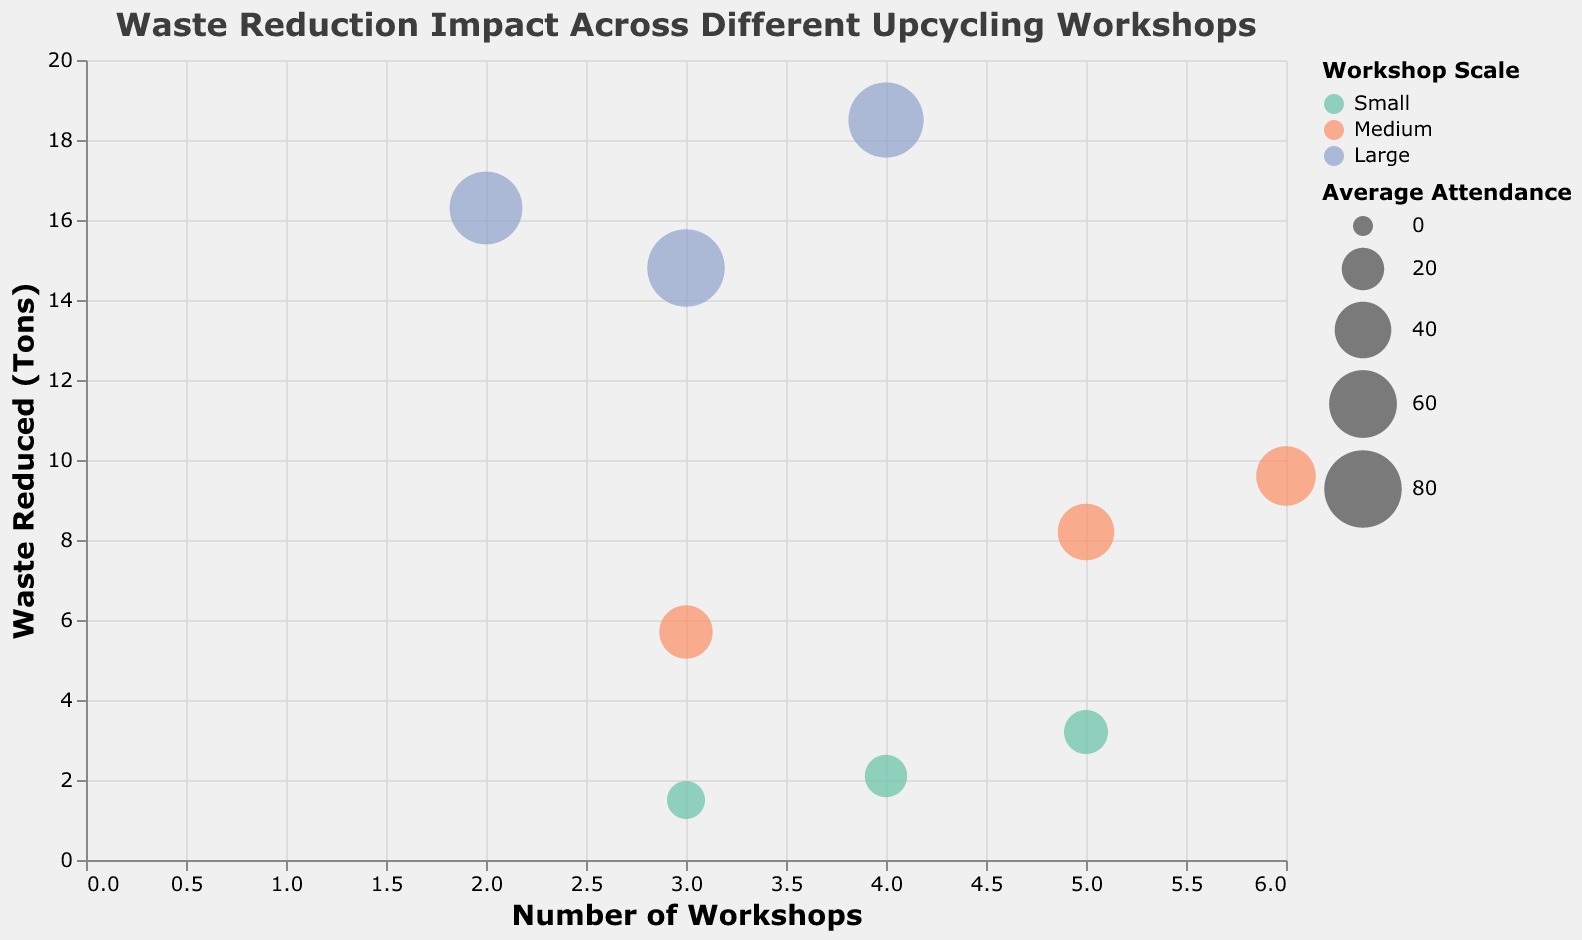What is the title of the chart? The chart title is displayed at the top of the figure.
Answer: "Waste Reduction Impact Across Different Upcycling Workshops" How many workshops are classified as 'Medium' scale? By looking at the color legend, we can count the number of bubbles colored according to the 'Medium' scale. There are three such workshops.
Answer: 3 Which workshop has the highest waste reduced in tons? Identify the highest point on the y-axis labeled 'Waste Reduced (Tons)' and check the tooltip for details.
Answer: "Grand Oak Refinishers" What is the average attendance for the 'Large' scale workshop with the smallest waste reduced in tons? Identify the smallest bubble among the ones colored for the 'Large' scale and refer to its tooltip.
Answer: 70 How many workshops have reduced more than 10 tons of waste? Count the number of bubbles plotted above the '10' mark on the y-axis.
Answer: 5 Compare 'Urban Pioneers Timber' and 'North Woods Artisans' in terms of waste reduced and average attendance. Locate both workshops using the tooltip and compare their y-axis positions (waste reduced) and bubble sizes (average attendance).
Answer: Urban Pioneers Timber: 8.2 tons, 40 attendees; North Woods Artisans: 5.7 tons, 35 attendees Which workshop has the highest average attendance among 'Small' scale workshops? Identify the largest bubble among the 'Small' scale colored bubbles and refer to its tooltip.
Answer: "Copperfield Creations" What is the total number of workshops for 'Large' scale? Sum the 'Number of Workshops' values for all 'Large' scale workshops by checking their tooltips.
Answer: 9 For 'Medium' scale workshops, which one has reduced the most waste in tons? From the 'Medium' scale colored bubbles, identify the highest position on the y-axis and check its tooltip.
Answer: "Sunnydale Workshop Collective" What is the range of waste reduced by 'Small' scale workshops? Identify the smallest and largest y-axis positions of 'Small' scale colored bubbles and calculate the range.
Answer: 1.5 - 3.2 tons 